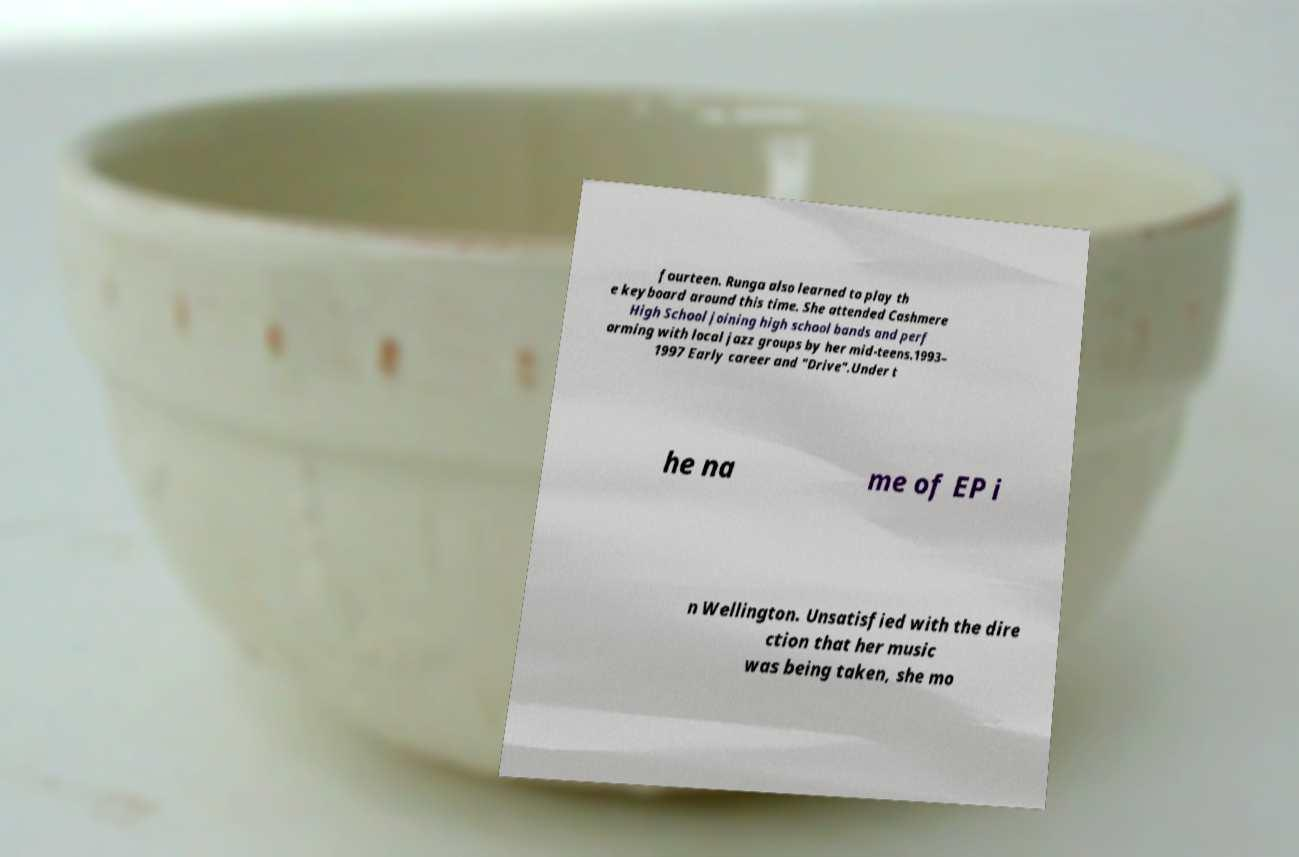Could you extract and type out the text from this image? fourteen. Runga also learned to play th e keyboard around this time. She attended Cashmere High School joining high school bands and perf orming with local jazz groups by her mid-teens.1993– 1997 Early career and "Drive".Under t he na me of EP i n Wellington. Unsatisfied with the dire ction that her music was being taken, she mo 